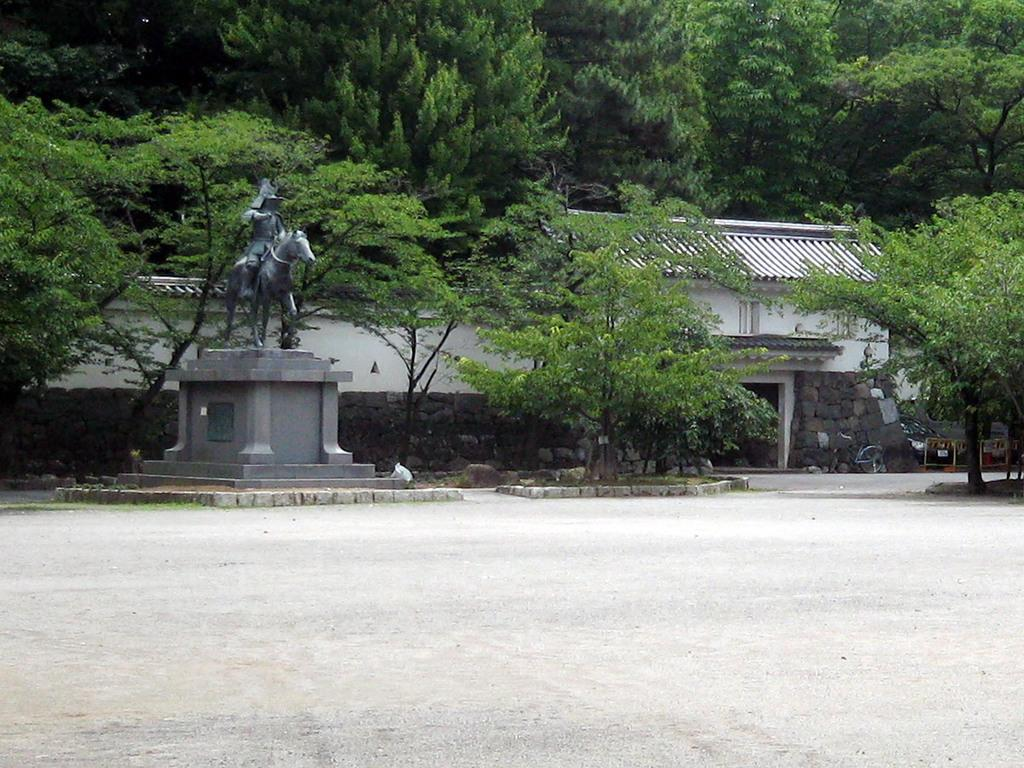What type of vegetation can be seen in the image? There are trees in the image. What structure is visible in the image? There is a wall in the image. What is located in front of the wall? There is a statue in front of the wall. What type of apparel is the statue wearing in the image? There is no apparel present on the statue in the image, as statues are typically not dressed in clothing. What is the purpose of the trees in the image? The purpose of the trees in the image cannot be determined from the image alone, as they may be decorative, provide shade, or serve other purposes. 